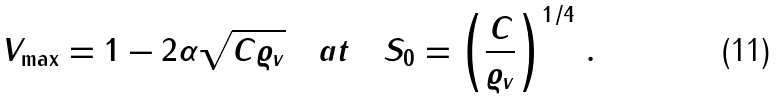Convert formula to latex. <formula><loc_0><loc_0><loc_500><loc_500>V _ { \max } = 1 - 2 \alpha \sqrt { C \varrho _ { v } } \quad a t \quad S _ { 0 } = \left ( \frac { C } { \varrho _ { v } } \right ) ^ { 1 / 4 } \, .</formula> 